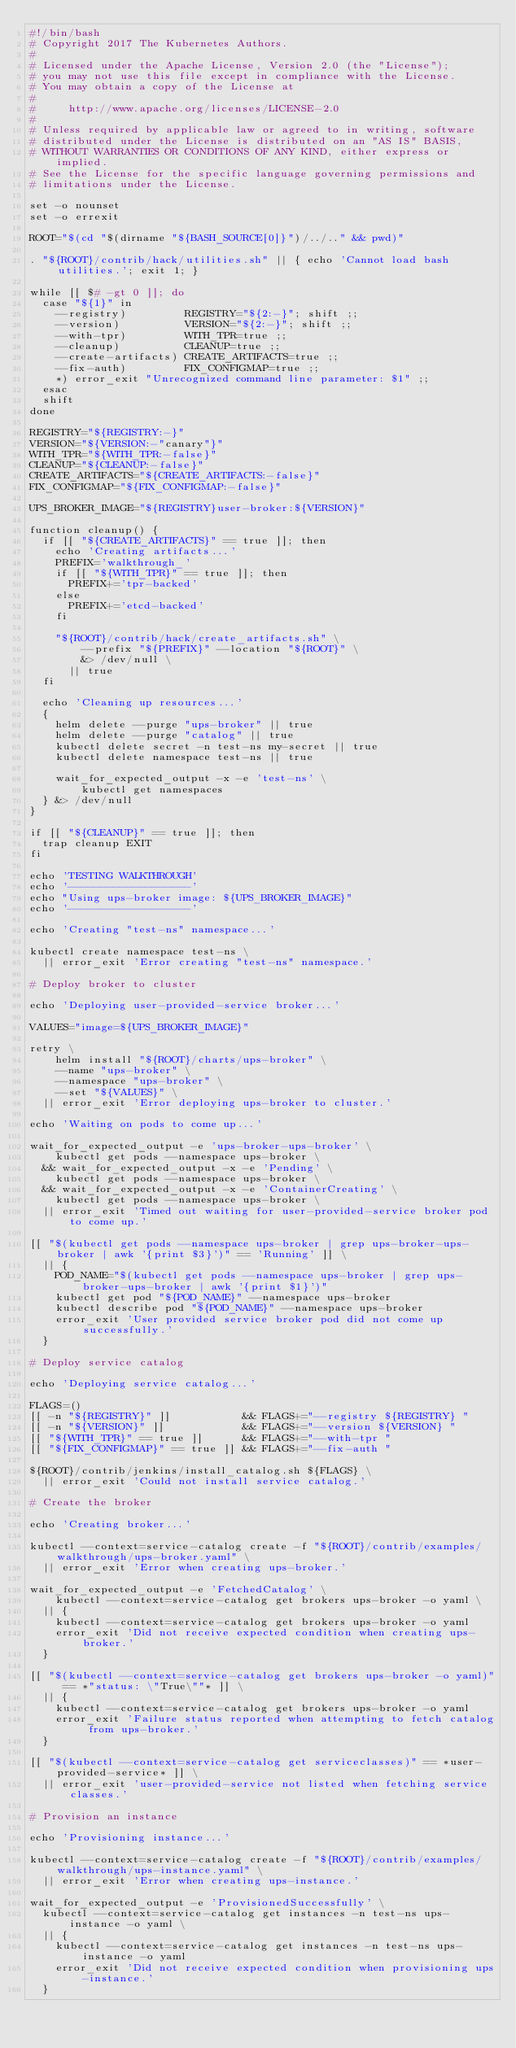Convert code to text. <code><loc_0><loc_0><loc_500><loc_500><_Bash_>#!/bin/bash
# Copyright 2017 The Kubernetes Authors.
#
# Licensed under the Apache License, Version 2.0 (the "License");
# you may not use this file except in compliance with the License.
# You may obtain a copy of the License at
#
#     http://www.apache.org/licenses/LICENSE-2.0
#
# Unless required by applicable law or agreed to in writing, software
# distributed under the License is distributed on an "AS IS" BASIS,
# WITHOUT WARRANTIES OR CONDITIONS OF ANY KIND, either express or implied.
# See the License for the specific language governing permissions and
# limitations under the License.

set -o nounset
set -o errexit

ROOT="$(cd "$(dirname "${BASH_SOURCE[0]}")/../.." && pwd)"

. "${ROOT}/contrib/hack/utilities.sh" || { echo 'Cannot load bash utilities.'; exit 1; }

while [[ $# -gt 0 ]]; do
  case "${1}" in
    --registry)         REGISTRY="${2:-}"; shift ;;
    --version)          VERSION="${2:-}"; shift ;;
    --with-tpr)         WITH_TPR=true ;;
    --cleanup)          CLEANUP=true ;;
    --create-artifacts) CREATE_ARTIFACTS=true ;;
    --fix-auth)         FIX_CONFIGMAP=true ;;
    *) error_exit "Unrecognized command line parameter: $1" ;;
  esac
  shift
done

REGISTRY="${REGISTRY:-}"
VERSION="${VERSION:-"canary"}"
WITH_TPR="${WITH_TPR:-false}"
CLEANUP="${CLEANUP:-false}"
CREATE_ARTIFACTS="${CREATE_ARTIFACTS:-false}"
FIX_CONFIGMAP="${FIX_CONFIGMAP:-false}"

UPS_BROKER_IMAGE="${REGISTRY}user-broker:${VERSION}"

function cleanup() {
  if [[ "${CREATE_ARTIFACTS}" == true ]]; then
    echo 'Creating artifacts...'
    PREFIX='walkthrough_'
    if [[ "${WITH_TPR}" == true ]]; then
      PREFIX+='tpr-backed'
    else
      PREFIX+='etcd-backed'
    fi

    "${ROOT}/contrib/hack/create_artifacts.sh" \
        --prefix "${PREFIX}" --location "${ROOT}" \
        &> /dev/null \
      || true
  fi

  echo 'Cleaning up resources...'
  {
    helm delete --purge "ups-broker" || true
    helm delete --purge "catalog" || true
    kubectl delete secret -n test-ns my-secret || true
    kubectl delete namespace test-ns || true

    wait_for_expected_output -x -e 'test-ns' \
        kubectl get namespaces
  } &> /dev/null
}

if [[ "${CLEANUP}" == true ]]; then
  trap cleanup EXIT
fi

echo 'TESTING WALKTHROUGH'
echo '-------------------'
echo "Using ups-broker image: ${UPS_BROKER_IMAGE}"
echo '-------------------'

echo 'Creating "test-ns" namespace...'

kubectl create namespace test-ns \
  || error_exit 'Error creating "test-ns" namespace.'

# Deploy broker to cluster

echo 'Deploying user-provided-service broker...'

VALUES="image=${UPS_BROKER_IMAGE}"

retry \
    helm install "${ROOT}/charts/ups-broker" \
    --name "ups-broker" \
    --namespace "ups-broker" \
    --set "${VALUES}" \
  || error_exit 'Error deploying ups-broker to cluster.'

echo 'Waiting on pods to come up...'

wait_for_expected_output -e 'ups-broker-ups-broker' \
    kubectl get pods --namespace ups-broker \
  && wait_for_expected_output -x -e 'Pending' \
    kubectl get pods --namespace ups-broker \
  && wait_for_expected_output -x -e 'ContainerCreating' \
    kubectl get pods --namespace ups-broker \
  || error_exit 'Timed out waiting for user-provided-service broker pod to come up.'

[[ "$(kubectl get pods --namespace ups-broker | grep ups-broker-ups-broker | awk '{print $3}')" == 'Running' ]] \
  || {
    POD_NAME="$(kubectl get pods --namespace ups-broker | grep ups-broker-ups-broker | awk '{print $1}')"
    kubectl get pod "${POD_NAME}" --namespace ups-broker
    kubectl describe pod "${POD_NAME}" --namespace ups-broker
    error_exit 'User provided service broker pod did not come up successfully.'
  }

# Deploy service catalog

echo 'Deploying service catalog...'

FLAGS=()
[[ -n "${REGISTRY}" ]]           && FLAGS+="--registry ${REGISTRY} "
[[ -n "${VERSION}" ]]            && FLAGS+="--version ${VERSION} "
[[ "${WITH_TPR}" == true ]]      && FLAGS+="--with-tpr "
[[ "${FIX_CONFIGMAP}" == true ]] && FLAGS+="--fix-auth "

${ROOT}/contrib/jenkins/install_catalog.sh ${FLAGS} \
  || error_exit 'Could not install service catalog.'

# Create the broker

echo 'Creating broker...'

kubectl --context=service-catalog create -f "${ROOT}/contrib/examples/walkthrough/ups-broker.yaml" \
  || error_exit 'Error when creating ups-broker.'

wait_for_expected_output -e 'FetchedCatalog' \
    kubectl --context=service-catalog get brokers ups-broker -o yaml \
  || {
    kubectl --context=service-catalog get brokers ups-broker -o yaml
    error_exit 'Did not receive expected condition when creating ups-broker.'
  }

[[ "$(kubectl --context=service-catalog get brokers ups-broker -o yaml)" == *"status: \"True\""* ]] \
  || {
    kubectl --context=service-catalog get brokers ups-broker -o yaml
    error_exit 'Failure status reported when attempting to fetch catalog from ups-broker.'
  }

[[ "$(kubectl --context=service-catalog get serviceclasses)" == *user-provided-service* ]] \
  || error_exit 'user-provided-service not listed when fetching service classes.'

# Provision an instance

echo 'Provisioning instance...'

kubectl --context=service-catalog create -f "${ROOT}/contrib/examples/walkthrough/ups-instance.yaml" \
  || error_exit 'Error when creating ups-instance.'

wait_for_expected_output -e 'ProvisionedSuccessfully' \
  kubectl --context=service-catalog get instances -n test-ns ups-instance -o yaml \
  || {
    kubectl --context=service-catalog get instances -n test-ns ups-instance -o yaml
    error_exit 'Did not receive expected condition when provisioning ups-instance.'
  }
</code> 